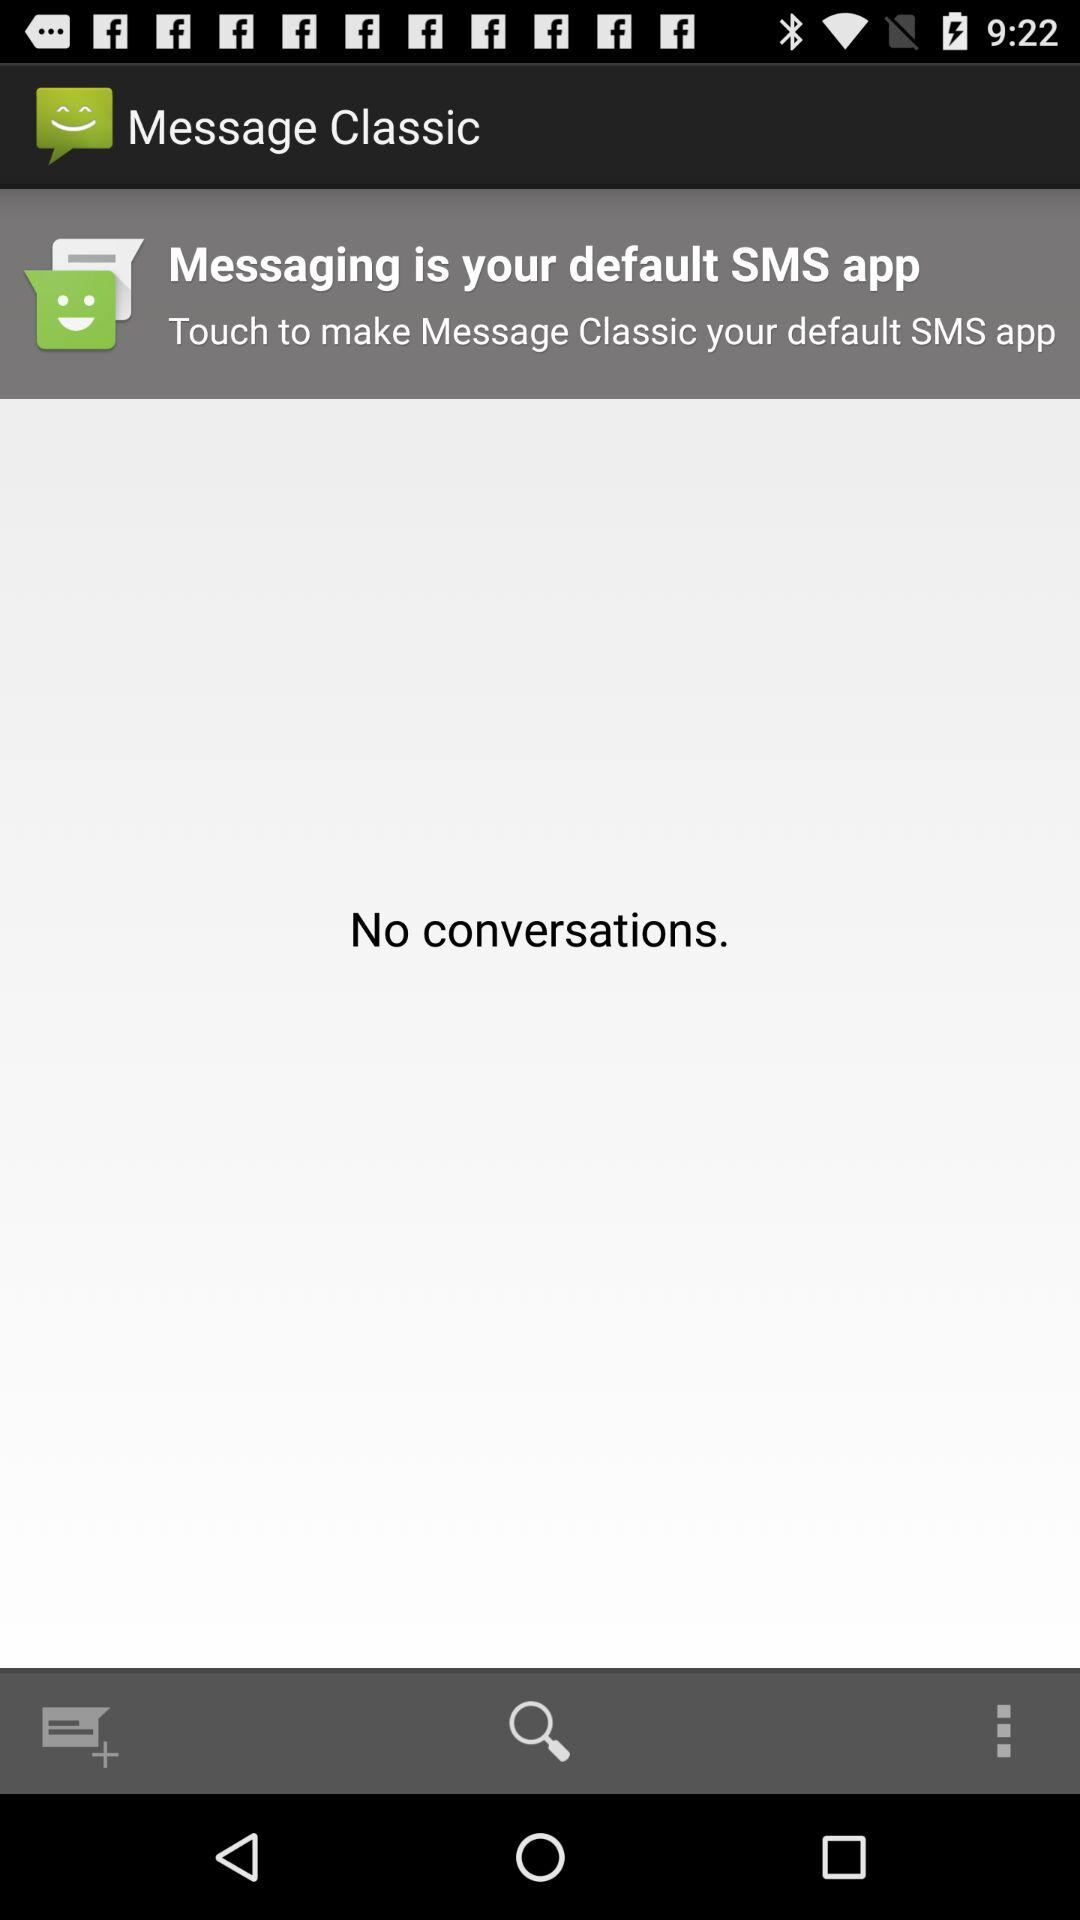What is the user's name?
When the provided information is insufficient, respond with <no answer>. <no answer> 